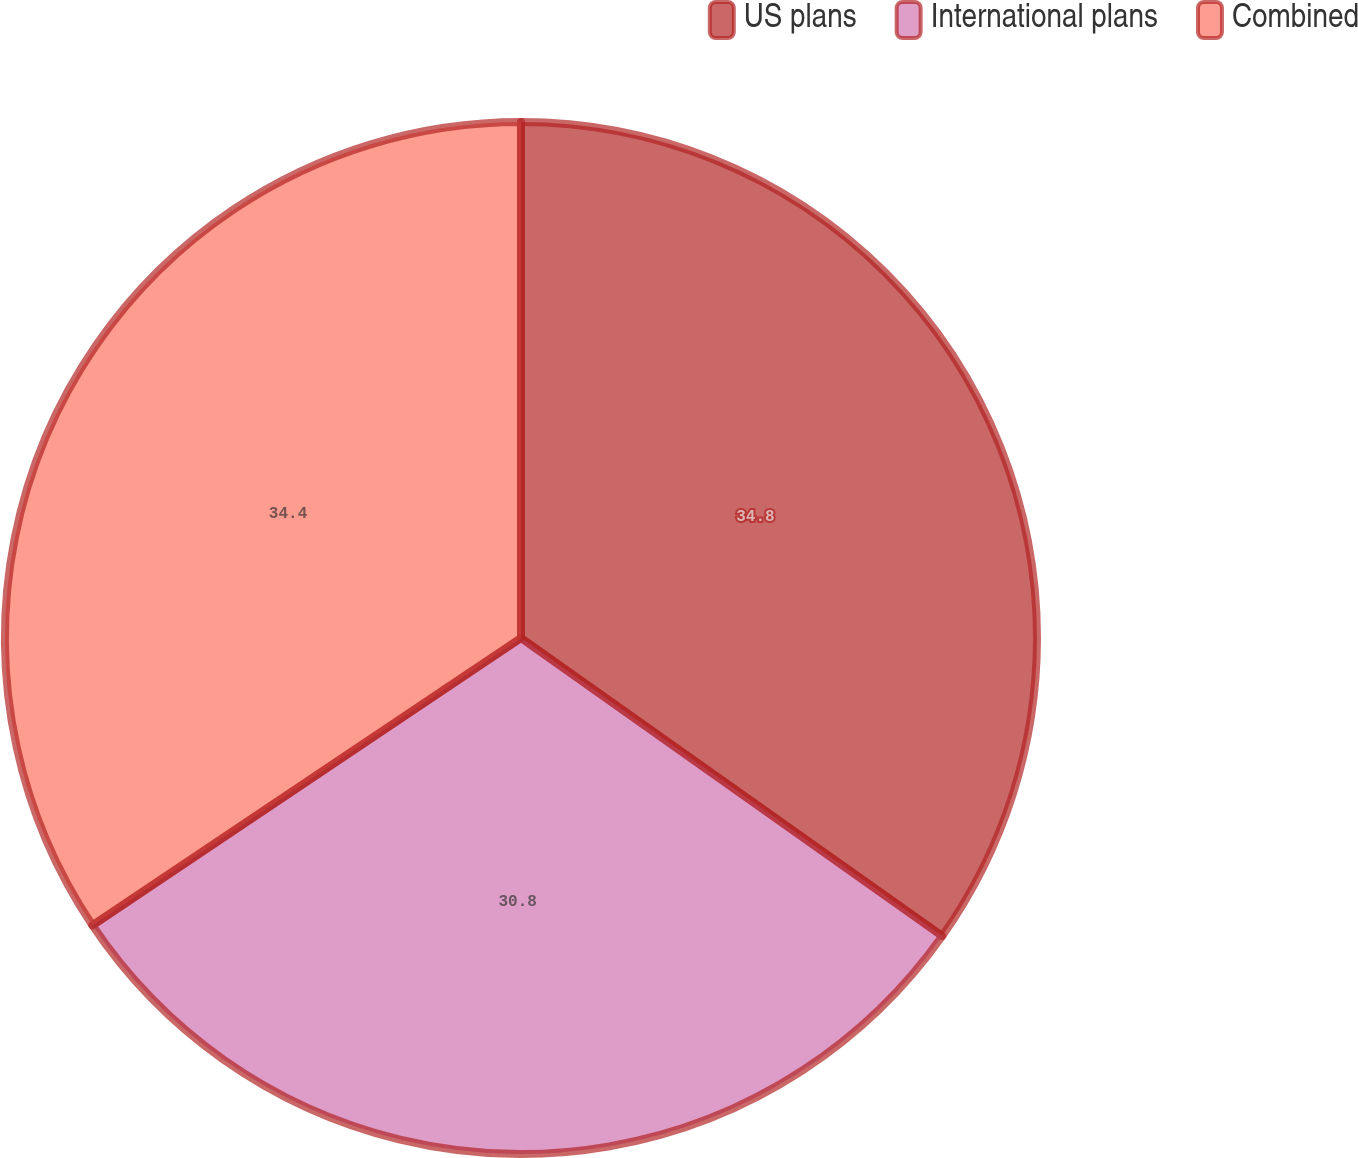Convert chart to OTSL. <chart><loc_0><loc_0><loc_500><loc_500><pie_chart><fcel>US plans<fcel>International plans<fcel>Combined<nl><fcel>34.8%<fcel>30.8%<fcel>34.4%<nl></chart> 